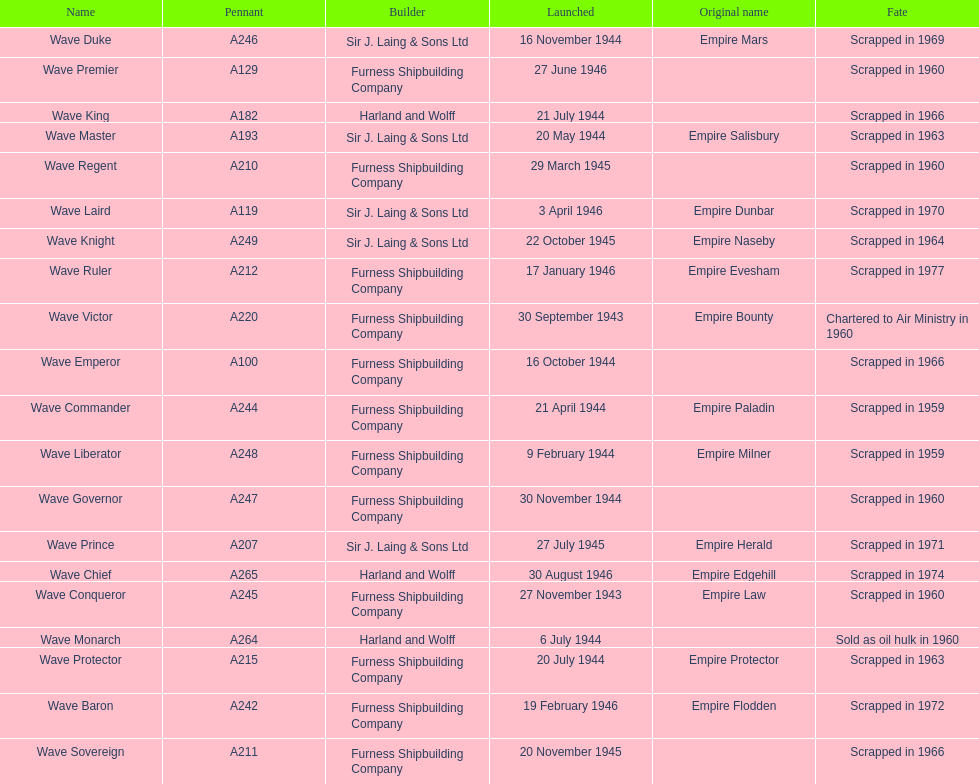How many ships were launched in the year 1944? 9. 